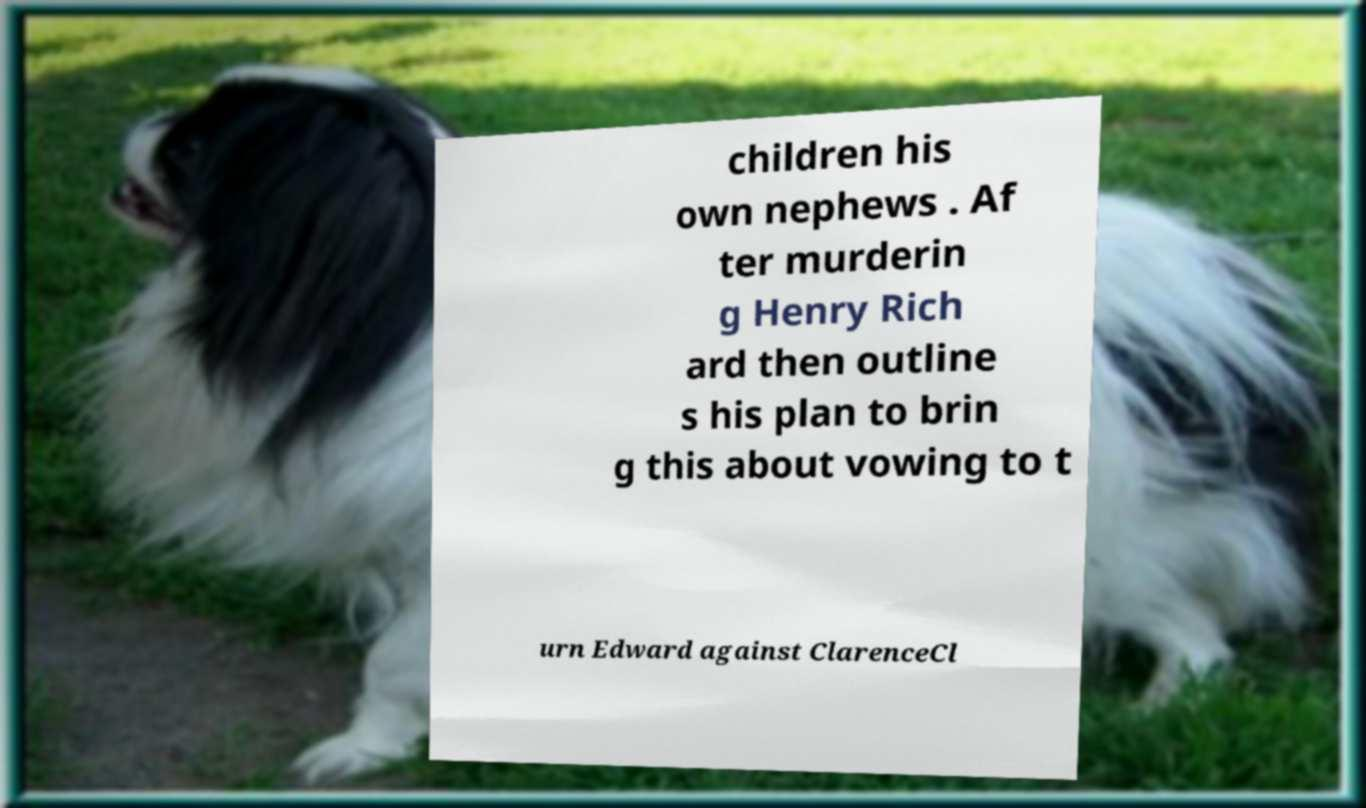Can you accurately transcribe the text from the provided image for me? children his own nephews . Af ter murderin g Henry Rich ard then outline s his plan to brin g this about vowing to t urn Edward against ClarenceCl 